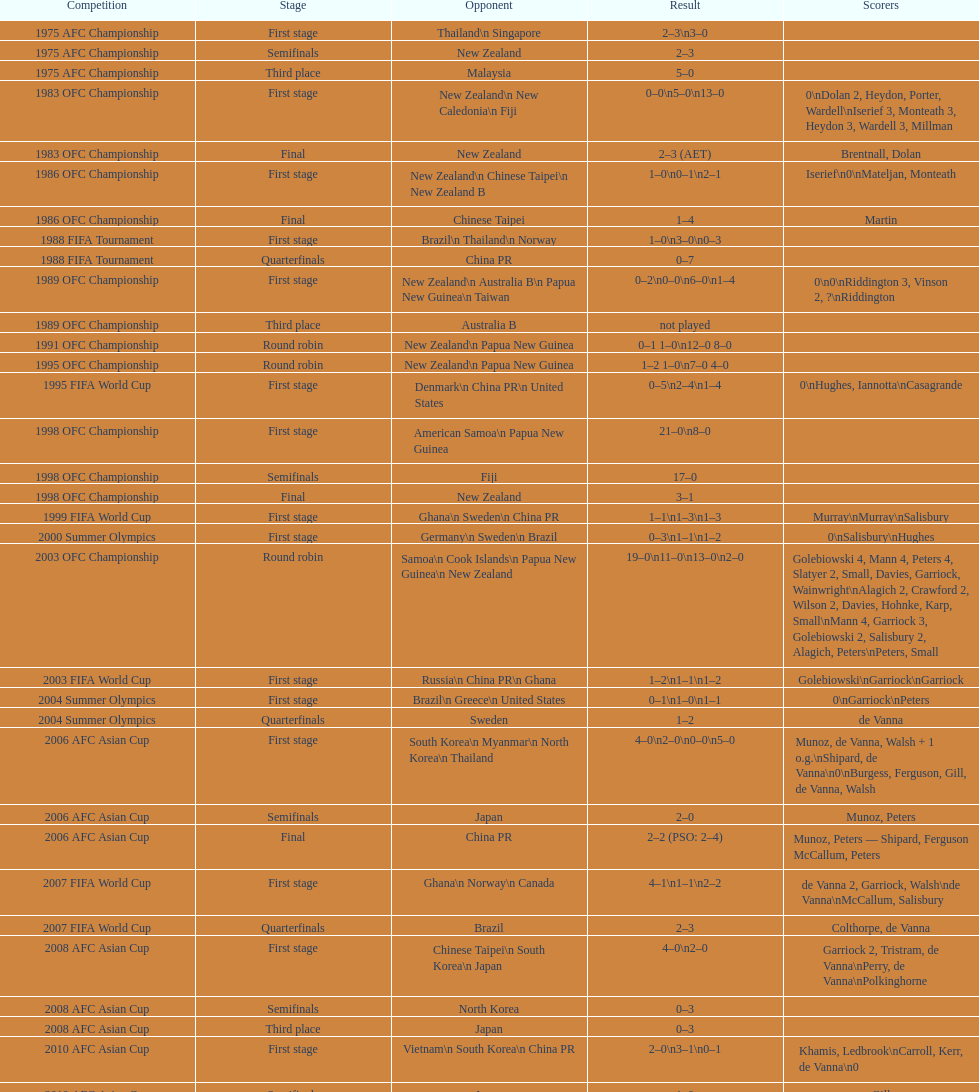In round robins, what was the total count of stages? 3. 